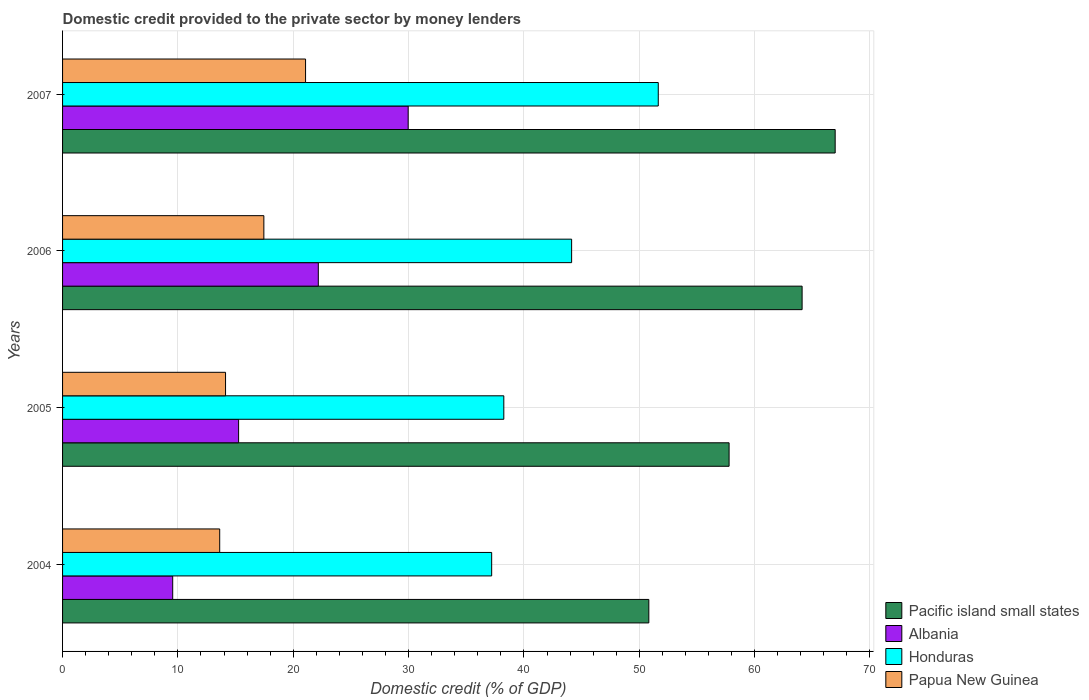How many bars are there on the 3rd tick from the top?
Your answer should be very brief. 4. What is the domestic credit provided to the private sector by money lenders in Papua New Guinea in 2006?
Your response must be concise. 17.45. Across all years, what is the maximum domestic credit provided to the private sector by money lenders in Pacific island small states?
Keep it short and to the point. 66.99. Across all years, what is the minimum domestic credit provided to the private sector by money lenders in Pacific island small states?
Provide a succinct answer. 50.83. In which year was the domestic credit provided to the private sector by money lenders in Albania minimum?
Your answer should be very brief. 2004. What is the total domestic credit provided to the private sector by money lenders in Pacific island small states in the graph?
Give a very brief answer. 239.72. What is the difference between the domestic credit provided to the private sector by money lenders in Pacific island small states in 2004 and that in 2006?
Offer a very short reply. -13.29. What is the difference between the domestic credit provided to the private sector by money lenders in Papua New Guinea in 2006 and the domestic credit provided to the private sector by money lenders in Honduras in 2005?
Offer a terse response. -20.8. What is the average domestic credit provided to the private sector by money lenders in Albania per year?
Offer a very short reply. 19.24. In the year 2006, what is the difference between the domestic credit provided to the private sector by money lenders in Albania and domestic credit provided to the private sector by money lenders in Pacific island small states?
Offer a very short reply. -41.95. In how many years, is the domestic credit provided to the private sector by money lenders in Honduras greater than 62 %?
Ensure brevity in your answer.  0. What is the ratio of the domestic credit provided to the private sector by money lenders in Albania in 2006 to that in 2007?
Provide a succinct answer. 0.74. Is the domestic credit provided to the private sector by money lenders in Albania in 2004 less than that in 2007?
Your answer should be compact. Yes. Is the difference between the domestic credit provided to the private sector by money lenders in Albania in 2005 and 2007 greater than the difference between the domestic credit provided to the private sector by money lenders in Pacific island small states in 2005 and 2007?
Offer a terse response. No. What is the difference between the highest and the second highest domestic credit provided to the private sector by money lenders in Papua New Guinea?
Ensure brevity in your answer.  3.62. What is the difference between the highest and the lowest domestic credit provided to the private sector by money lenders in Papua New Guinea?
Ensure brevity in your answer.  7.44. Is it the case that in every year, the sum of the domestic credit provided to the private sector by money lenders in Papua New Guinea and domestic credit provided to the private sector by money lenders in Pacific island small states is greater than the sum of domestic credit provided to the private sector by money lenders in Honduras and domestic credit provided to the private sector by money lenders in Albania?
Give a very brief answer. No. What does the 4th bar from the top in 2007 represents?
Provide a succinct answer. Pacific island small states. What does the 3rd bar from the bottom in 2006 represents?
Your response must be concise. Honduras. Are all the bars in the graph horizontal?
Make the answer very short. Yes. Are the values on the major ticks of X-axis written in scientific E-notation?
Your response must be concise. No. Does the graph contain any zero values?
Provide a succinct answer. No. Where does the legend appear in the graph?
Your response must be concise. Bottom right. How many legend labels are there?
Your answer should be compact. 4. What is the title of the graph?
Make the answer very short. Domestic credit provided to the private sector by money lenders. What is the label or title of the X-axis?
Keep it short and to the point. Domestic credit (% of GDP). What is the Domestic credit (% of GDP) in Pacific island small states in 2004?
Provide a succinct answer. 50.83. What is the Domestic credit (% of GDP) in Albania in 2004?
Keep it short and to the point. 9.55. What is the Domestic credit (% of GDP) in Honduras in 2004?
Your answer should be compact. 37.2. What is the Domestic credit (% of GDP) in Papua New Guinea in 2004?
Make the answer very short. 13.62. What is the Domestic credit (% of GDP) of Pacific island small states in 2005?
Make the answer very short. 57.79. What is the Domestic credit (% of GDP) in Albania in 2005?
Your response must be concise. 15.26. What is the Domestic credit (% of GDP) of Honduras in 2005?
Offer a terse response. 38.26. What is the Domestic credit (% of GDP) in Papua New Guinea in 2005?
Give a very brief answer. 14.13. What is the Domestic credit (% of GDP) in Pacific island small states in 2006?
Give a very brief answer. 64.12. What is the Domestic credit (% of GDP) in Albania in 2006?
Provide a succinct answer. 22.17. What is the Domestic credit (% of GDP) of Honduras in 2006?
Your response must be concise. 44.14. What is the Domestic credit (% of GDP) of Papua New Guinea in 2006?
Offer a very short reply. 17.45. What is the Domestic credit (% of GDP) of Pacific island small states in 2007?
Give a very brief answer. 66.99. What is the Domestic credit (% of GDP) in Albania in 2007?
Provide a short and direct response. 29.96. What is the Domestic credit (% of GDP) of Honduras in 2007?
Provide a succinct answer. 51.65. What is the Domestic credit (% of GDP) of Papua New Guinea in 2007?
Offer a very short reply. 21.07. Across all years, what is the maximum Domestic credit (% of GDP) of Pacific island small states?
Your answer should be compact. 66.99. Across all years, what is the maximum Domestic credit (% of GDP) of Albania?
Your response must be concise. 29.96. Across all years, what is the maximum Domestic credit (% of GDP) of Honduras?
Make the answer very short. 51.65. Across all years, what is the maximum Domestic credit (% of GDP) of Papua New Guinea?
Your answer should be very brief. 21.07. Across all years, what is the minimum Domestic credit (% of GDP) in Pacific island small states?
Provide a short and direct response. 50.83. Across all years, what is the minimum Domestic credit (% of GDP) of Albania?
Provide a short and direct response. 9.55. Across all years, what is the minimum Domestic credit (% of GDP) in Honduras?
Your answer should be very brief. 37.2. Across all years, what is the minimum Domestic credit (% of GDP) of Papua New Guinea?
Your answer should be compact. 13.62. What is the total Domestic credit (% of GDP) in Pacific island small states in the graph?
Provide a short and direct response. 239.72. What is the total Domestic credit (% of GDP) of Albania in the graph?
Give a very brief answer. 76.95. What is the total Domestic credit (% of GDP) of Honduras in the graph?
Offer a terse response. 171.24. What is the total Domestic credit (% of GDP) in Papua New Guinea in the graph?
Offer a terse response. 66.27. What is the difference between the Domestic credit (% of GDP) of Pacific island small states in 2004 and that in 2005?
Make the answer very short. -6.96. What is the difference between the Domestic credit (% of GDP) in Albania in 2004 and that in 2005?
Keep it short and to the point. -5.71. What is the difference between the Domestic credit (% of GDP) of Honduras in 2004 and that in 2005?
Make the answer very short. -1.05. What is the difference between the Domestic credit (% of GDP) in Papua New Guinea in 2004 and that in 2005?
Offer a terse response. -0.51. What is the difference between the Domestic credit (% of GDP) of Pacific island small states in 2004 and that in 2006?
Provide a succinct answer. -13.29. What is the difference between the Domestic credit (% of GDP) in Albania in 2004 and that in 2006?
Make the answer very short. -12.62. What is the difference between the Domestic credit (% of GDP) of Honduras in 2004 and that in 2006?
Offer a very short reply. -6.93. What is the difference between the Domestic credit (% of GDP) of Papua New Guinea in 2004 and that in 2006?
Provide a succinct answer. -3.83. What is the difference between the Domestic credit (% of GDP) of Pacific island small states in 2004 and that in 2007?
Provide a succinct answer. -16.16. What is the difference between the Domestic credit (% of GDP) in Albania in 2004 and that in 2007?
Offer a terse response. -20.41. What is the difference between the Domestic credit (% of GDP) in Honduras in 2004 and that in 2007?
Provide a succinct answer. -14.44. What is the difference between the Domestic credit (% of GDP) in Papua New Guinea in 2004 and that in 2007?
Provide a succinct answer. -7.44. What is the difference between the Domestic credit (% of GDP) of Pacific island small states in 2005 and that in 2006?
Your response must be concise. -6.33. What is the difference between the Domestic credit (% of GDP) of Albania in 2005 and that in 2006?
Give a very brief answer. -6.91. What is the difference between the Domestic credit (% of GDP) in Honduras in 2005 and that in 2006?
Your response must be concise. -5.88. What is the difference between the Domestic credit (% of GDP) of Papua New Guinea in 2005 and that in 2006?
Your answer should be very brief. -3.32. What is the difference between the Domestic credit (% of GDP) in Pacific island small states in 2005 and that in 2007?
Give a very brief answer. -9.2. What is the difference between the Domestic credit (% of GDP) of Albania in 2005 and that in 2007?
Offer a very short reply. -14.7. What is the difference between the Domestic credit (% of GDP) of Honduras in 2005 and that in 2007?
Give a very brief answer. -13.39. What is the difference between the Domestic credit (% of GDP) of Papua New Guinea in 2005 and that in 2007?
Your answer should be very brief. -6.94. What is the difference between the Domestic credit (% of GDP) of Pacific island small states in 2006 and that in 2007?
Provide a short and direct response. -2.87. What is the difference between the Domestic credit (% of GDP) in Albania in 2006 and that in 2007?
Give a very brief answer. -7.79. What is the difference between the Domestic credit (% of GDP) of Honduras in 2006 and that in 2007?
Your response must be concise. -7.51. What is the difference between the Domestic credit (% of GDP) of Papua New Guinea in 2006 and that in 2007?
Give a very brief answer. -3.62. What is the difference between the Domestic credit (% of GDP) in Pacific island small states in 2004 and the Domestic credit (% of GDP) in Albania in 2005?
Ensure brevity in your answer.  35.57. What is the difference between the Domestic credit (% of GDP) of Pacific island small states in 2004 and the Domestic credit (% of GDP) of Honduras in 2005?
Your answer should be very brief. 12.57. What is the difference between the Domestic credit (% of GDP) in Pacific island small states in 2004 and the Domestic credit (% of GDP) in Papua New Guinea in 2005?
Offer a very short reply. 36.7. What is the difference between the Domestic credit (% of GDP) in Albania in 2004 and the Domestic credit (% of GDP) in Honduras in 2005?
Your response must be concise. -28.71. What is the difference between the Domestic credit (% of GDP) in Albania in 2004 and the Domestic credit (% of GDP) in Papua New Guinea in 2005?
Make the answer very short. -4.58. What is the difference between the Domestic credit (% of GDP) in Honduras in 2004 and the Domestic credit (% of GDP) in Papua New Guinea in 2005?
Your response must be concise. 23.07. What is the difference between the Domestic credit (% of GDP) in Pacific island small states in 2004 and the Domestic credit (% of GDP) in Albania in 2006?
Make the answer very short. 28.66. What is the difference between the Domestic credit (% of GDP) of Pacific island small states in 2004 and the Domestic credit (% of GDP) of Honduras in 2006?
Make the answer very short. 6.69. What is the difference between the Domestic credit (% of GDP) of Pacific island small states in 2004 and the Domestic credit (% of GDP) of Papua New Guinea in 2006?
Keep it short and to the point. 33.38. What is the difference between the Domestic credit (% of GDP) in Albania in 2004 and the Domestic credit (% of GDP) in Honduras in 2006?
Make the answer very short. -34.59. What is the difference between the Domestic credit (% of GDP) in Albania in 2004 and the Domestic credit (% of GDP) in Papua New Guinea in 2006?
Offer a terse response. -7.9. What is the difference between the Domestic credit (% of GDP) in Honduras in 2004 and the Domestic credit (% of GDP) in Papua New Guinea in 2006?
Make the answer very short. 19.75. What is the difference between the Domestic credit (% of GDP) of Pacific island small states in 2004 and the Domestic credit (% of GDP) of Albania in 2007?
Offer a very short reply. 20.86. What is the difference between the Domestic credit (% of GDP) of Pacific island small states in 2004 and the Domestic credit (% of GDP) of Honduras in 2007?
Your answer should be very brief. -0.82. What is the difference between the Domestic credit (% of GDP) in Pacific island small states in 2004 and the Domestic credit (% of GDP) in Papua New Guinea in 2007?
Keep it short and to the point. 29.76. What is the difference between the Domestic credit (% of GDP) of Albania in 2004 and the Domestic credit (% of GDP) of Honduras in 2007?
Provide a succinct answer. -42.1. What is the difference between the Domestic credit (% of GDP) in Albania in 2004 and the Domestic credit (% of GDP) in Papua New Guinea in 2007?
Your response must be concise. -11.52. What is the difference between the Domestic credit (% of GDP) in Honduras in 2004 and the Domestic credit (% of GDP) in Papua New Guinea in 2007?
Your answer should be compact. 16.14. What is the difference between the Domestic credit (% of GDP) in Pacific island small states in 2005 and the Domestic credit (% of GDP) in Albania in 2006?
Give a very brief answer. 35.61. What is the difference between the Domestic credit (% of GDP) in Pacific island small states in 2005 and the Domestic credit (% of GDP) in Honduras in 2006?
Keep it short and to the point. 13.65. What is the difference between the Domestic credit (% of GDP) of Pacific island small states in 2005 and the Domestic credit (% of GDP) of Papua New Guinea in 2006?
Offer a very short reply. 40.34. What is the difference between the Domestic credit (% of GDP) of Albania in 2005 and the Domestic credit (% of GDP) of Honduras in 2006?
Make the answer very short. -28.87. What is the difference between the Domestic credit (% of GDP) in Albania in 2005 and the Domestic credit (% of GDP) in Papua New Guinea in 2006?
Keep it short and to the point. -2.19. What is the difference between the Domestic credit (% of GDP) in Honduras in 2005 and the Domestic credit (% of GDP) in Papua New Guinea in 2006?
Your answer should be very brief. 20.8. What is the difference between the Domestic credit (% of GDP) in Pacific island small states in 2005 and the Domestic credit (% of GDP) in Albania in 2007?
Keep it short and to the point. 27.82. What is the difference between the Domestic credit (% of GDP) of Pacific island small states in 2005 and the Domestic credit (% of GDP) of Honduras in 2007?
Your answer should be very brief. 6.14. What is the difference between the Domestic credit (% of GDP) of Pacific island small states in 2005 and the Domestic credit (% of GDP) of Papua New Guinea in 2007?
Keep it short and to the point. 36.72. What is the difference between the Domestic credit (% of GDP) in Albania in 2005 and the Domestic credit (% of GDP) in Honduras in 2007?
Keep it short and to the point. -36.38. What is the difference between the Domestic credit (% of GDP) in Albania in 2005 and the Domestic credit (% of GDP) in Papua New Guinea in 2007?
Keep it short and to the point. -5.8. What is the difference between the Domestic credit (% of GDP) of Honduras in 2005 and the Domestic credit (% of GDP) of Papua New Guinea in 2007?
Offer a very short reply. 17.19. What is the difference between the Domestic credit (% of GDP) of Pacific island small states in 2006 and the Domestic credit (% of GDP) of Albania in 2007?
Provide a succinct answer. 34.15. What is the difference between the Domestic credit (% of GDP) in Pacific island small states in 2006 and the Domestic credit (% of GDP) in Honduras in 2007?
Give a very brief answer. 12.47. What is the difference between the Domestic credit (% of GDP) in Pacific island small states in 2006 and the Domestic credit (% of GDP) in Papua New Guinea in 2007?
Make the answer very short. 43.05. What is the difference between the Domestic credit (% of GDP) in Albania in 2006 and the Domestic credit (% of GDP) in Honduras in 2007?
Provide a short and direct response. -29.47. What is the difference between the Domestic credit (% of GDP) of Albania in 2006 and the Domestic credit (% of GDP) of Papua New Guinea in 2007?
Offer a very short reply. 1.11. What is the difference between the Domestic credit (% of GDP) of Honduras in 2006 and the Domestic credit (% of GDP) of Papua New Guinea in 2007?
Ensure brevity in your answer.  23.07. What is the average Domestic credit (% of GDP) in Pacific island small states per year?
Provide a succinct answer. 59.93. What is the average Domestic credit (% of GDP) of Albania per year?
Offer a terse response. 19.24. What is the average Domestic credit (% of GDP) in Honduras per year?
Provide a short and direct response. 42.81. What is the average Domestic credit (% of GDP) in Papua New Guinea per year?
Keep it short and to the point. 16.57. In the year 2004, what is the difference between the Domestic credit (% of GDP) in Pacific island small states and Domestic credit (% of GDP) in Albania?
Provide a succinct answer. 41.28. In the year 2004, what is the difference between the Domestic credit (% of GDP) in Pacific island small states and Domestic credit (% of GDP) in Honduras?
Your response must be concise. 13.62. In the year 2004, what is the difference between the Domestic credit (% of GDP) in Pacific island small states and Domestic credit (% of GDP) in Papua New Guinea?
Provide a short and direct response. 37.21. In the year 2004, what is the difference between the Domestic credit (% of GDP) in Albania and Domestic credit (% of GDP) in Honduras?
Your response must be concise. -27.65. In the year 2004, what is the difference between the Domestic credit (% of GDP) of Albania and Domestic credit (% of GDP) of Papua New Guinea?
Keep it short and to the point. -4.07. In the year 2004, what is the difference between the Domestic credit (% of GDP) in Honduras and Domestic credit (% of GDP) in Papua New Guinea?
Your answer should be very brief. 23.58. In the year 2005, what is the difference between the Domestic credit (% of GDP) in Pacific island small states and Domestic credit (% of GDP) in Albania?
Give a very brief answer. 42.52. In the year 2005, what is the difference between the Domestic credit (% of GDP) in Pacific island small states and Domestic credit (% of GDP) in Honduras?
Ensure brevity in your answer.  19.53. In the year 2005, what is the difference between the Domestic credit (% of GDP) in Pacific island small states and Domestic credit (% of GDP) in Papua New Guinea?
Provide a succinct answer. 43.66. In the year 2005, what is the difference between the Domestic credit (% of GDP) in Albania and Domestic credit (% of GDP) in Honduras?
Your answer should be compact. -22.99. In the year 2005, what is the difference between the Domestic credit (% of GDP) of Albania and Domestic credit (% of GDP) of Papua New Guinea?
Offer a terse response. 1.13. In the year 2005, what is the difference between the Domestic credit (% of GDP) of Honduras and Domestic credit (% of GDP) of Papua New Guinea?
Provide a succinct answer. 24.13. In the year 2006, what is the difference between the Domestic credit (% of GDP) in Pacific island small states and Domestic credit (% of GDP) in Albania?
Make the answer very short. 41.95. In the year 2006, what is the difference between the Domestic credit (% of GDP) of Pacific island small states and Domestic credit (% of GDP) of Honduras?
Your answer should be compact. 19.98. In the year 2006, what is the difference between the Domestic credit (% of GDP) of Pacific island small states and Domestic credit (% of GDP) of Papua New Guinea?
Give a very brief answer. 46.67. In the year 2006, what is the difference between the Domestic credit (% of GDP) in Albania and Domestic credit (% of GDP) in Honduras?
Provide a short and direct response. -21.96. In the year 2006, what is the difference between the Domestic credit (% of GDP) of Albania and Domestic credit (% of GDP) of Papua New Guinea?
Provide a short and direct response. 4.72. In the year 2006, what is the difference between the Domestic credit (% of GDP) in Honduras and Domestic credit (% of GDP) in Papua New Guinea?
Your answer should be very brief. 26.68. In the year 2007, what is the difference between the Domestic credit (% of GDP) in Pacific island small states and Domestic credit (% of GDP) in Albania?
Make the answer very short. 37.02. In the year 2007, what is the difference between the Domestic credit (% of GDP) of Pacific island small states and Domestic credit (% of GDP) of Honduras?
Ensure brevity in your answer.  15.34. In the year 2007, what is the difference between the Domestic credit (% of GDP) of Pacific island small states and Domestic credit (% of GDP) of Papua New Guinea?
Offer a very short reply. 45.92. In the year 2007, what is the difference between the Domestic credit (% of GDP) in Albania and Domestic credit (% of GDP) in Honduras?
Ensure brevity in your answer.  -21.68. In the year 2007, what is the difference between the Domestic credit (% of GDP) in Albania and Domestic credit (% of GDP) in Papua New Guinea?
Ensure brevity in your answer.  8.9. In the year 2007, what is the difference between the Domestic credit (% of GDP) in Honduras and Domestic credit (% of GDP) in Papua New Guinea?
Offer a very short reply. 30.58. What is the ratio of the Domestic credit (% of GDP) of Pacific island small states in 2004 to that in 2005?
Your answer should be very brief. 0.88. What is the ratio of the Domestic credit (% of GDP) in Albania in 2004 to that in 2005?
Offer a very short reply. 0.63. What is the ratio of the Domestic credit (% of GDP) in Honduras in 2004 to that in 2005?
Make the answer very short. 0.97. What is the ratio of the Domestic credit (% of GDP) in Papua New Guinea in 2004 to that in 2005?
Your answer should be compact. 0.96. What is the ratio of the Domestic credit (% of GDP) of Pacific island small states in 2004 to that in 2006?
Offer a terse response. 0.79. What is the ratio of the Domestic credit (% of GDP) in Albania in 2004 to that in 2006?
Make the answer very short. 0.43. What is the ratio of the Domestic credit (% of GDP) of Honduras in 2004 to that in 2006?
Keep it short and to the point. 0.84. What is the ratio of the Domestic credit (% of GDP) in Papua New Guinea in 2004 to that in 2006?
Ensure brevity in your answer.  0.78. What is the ratio of the Domestic credit (% of GDP) in Pacific island small states in 2004 to that in 2007?
Offer a very short reply. 0.76. What is the ratio of the Domestic credit (% of GDP) of Albania in 2004 to that in 2007?
Offer a very short reply. 0.32. What is the ratio of the Domestic credit (% of GDP) of Honduras in 2004 to that in 2007?
Your answer should be compact. 0.72. What is the ratio of the Domestic credit (% of GDP) in Papua New Guinea in 2004 to that in 2007?
Your answer should be very brief. 0.65. What is the ratio of the Domestic credit (% of GDP) of Pacific island small states in 2005 to that in 2006?
Your answer should be compact. 0.9. What is the ratio of the Domestic credit (% of GDP) of Albania in 2005 to that in 2006?
Make the answer very short. 0.69. What is the ratio of the Domestic credit (% of GDP) of Honduras in 2005 to that in 2006?
Ensure brevity in your answer.  0.87. What is the ratio of the Domestic credit (% of GDP) in Papua New Guinea in 2005 to that in 2006?
Your answer should be very brief. 0.81. What is the ratio of the Domestic credit (% of GDP) of Pacific island small states in 2005 to that in 2007?
Keep it short and to the point. 0.86. What is the ratio of the Domestic credit (% of GDP) of Albania in 2005 to that in 2007?
Your answer should be compact. 0.51. What is the ratio of the Domestic credit (% of GDP) in Honduras in 2005 to that in 2007?
Ensure brevity in your answer.  0.74. What is the ratio of the Domestic credit (% of GDP) of Papua New Guinea in 2005 to that in 2007?
Give a very brief answer. 0.67. What is the ratio of the Domestic credit (% of GDP) of Pacific island small states in 2006 to that in 2007?
Your response must be concise. 0.96. What is the ratio of the Domestic credit (% of GDP) in Albania in 2006 to that in 2007?
Provide a succinct answer. 0.74. What is the ratio of the Domestic credit (% of GDP) in Honduras in 2006 to that in 2007?
Offer a terse response. 0.85. What is the ratio of the Domestic credit (% of GDP) in Papua New Guinea in 2006 to that in 2007?
Keep it short and to the point. 0.83. What is the difference between the highest and the second highest Domestic credit (% of GDP) of Pacific island small states?
Your response must be concise. 2.87. What is the difference between the highest and the second highest Domestic credit (% of GDP) of Albania?
Offer a very short reply. 7.79. What is the difference between the highest and the second highest Domestic credit (% of GDP) in Honduras?
Give a very brief answer. 7.51. What is the difference between the highest and the second highest Domestic credit (% of GDP) in Papua New Guinea?
Offer a very short reply. 3.62. What is the difference between the highest and the lowest Domestic credit (% of GDP) in Pacific island small states?
Your answer should be compact. 16.16. What is the difference between the highest and the lowest Domestic credit (% of GDP) in Albania?
Offer a very short reply. 20.41. What is the difference between the highest and the lowest Domestic credit (% of GDP) of Honduras?
Your response must be concise. 14.44. What is the difference between the highest and the lowest Domestic credit (% of GDP) of Papua New Guinea?
Offer a very short reply. 7.44. 